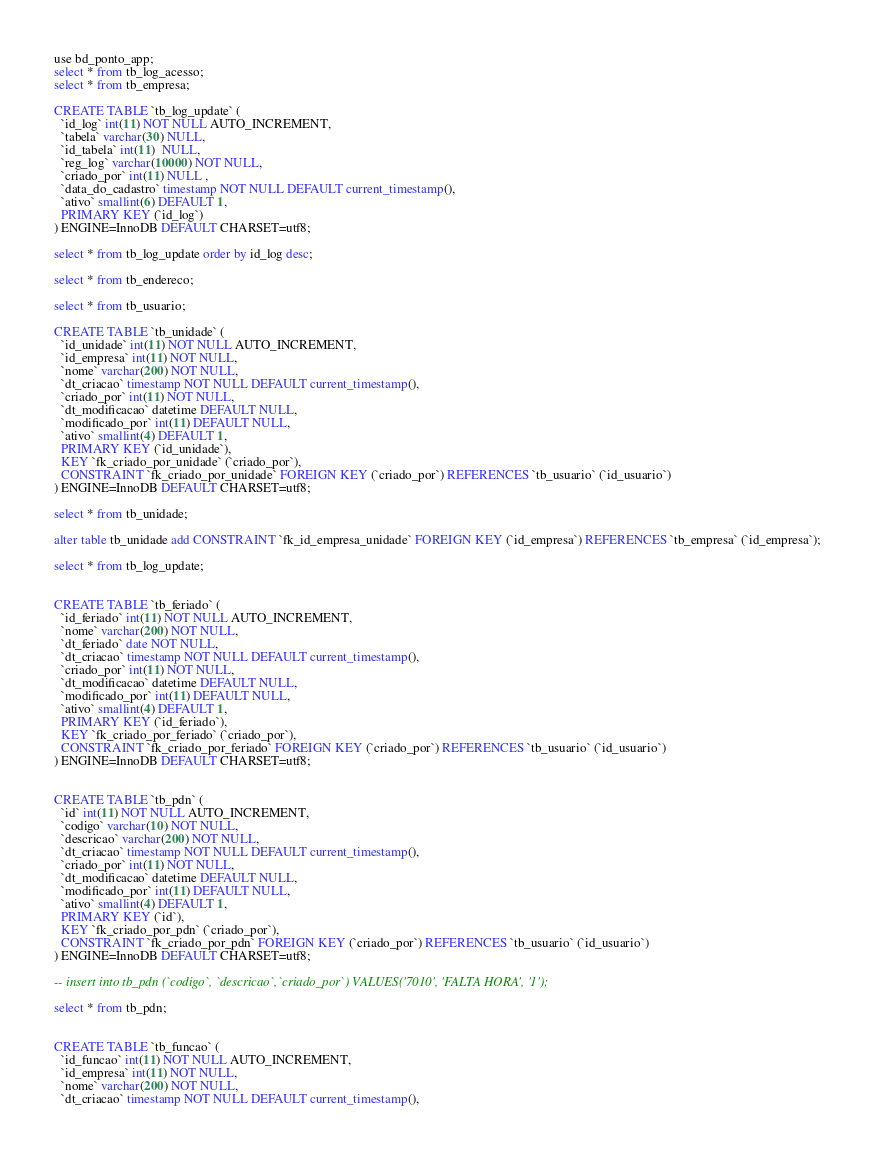Convert code to text. <code><loc_0><loc_0><loc_500><loc_500><_SQL_>use bd_ponto_app;
select * from tb_log_acesso;
select * from tb_empresa;

CREATE TABLE `tb_log_update` (
  `id_log` int(11) NOT NULL AUTO_INCREMENT,
  `tabela` varchar(30) NULL,
  `id_tabela` int(11)  NULL,
  `reg_log` varchar(10000) NOT NULL,
  `criado_por` int(11) NULL ,
  `data_do_cadastro` timestamp NOT NULL DEFAULT current_timestamp(),
  `ativo` smallint(6) DEFAULT 1,
  PRIMARY KEY (`id_log`)
) ENGINE=InnoDB DEFAULT CHARSET=utf8;

select * from tb_log_update order by id_log desc; 

select * from tb_endereco;

select * from tb_usuario;

CREATE TABLE `tb_unidade` (
  `id_unidade` int(11) NOT NULL AUTO_INCREMENT,
  `id_empresa` int(11) NOT NULL,
  `nome` varchar(200) NOT NULL,  
  `dt_criacao` timestamp NOT NULL DEFAULT current_timestamp(),
  `criado_por` int(11) NOT NULL,
  `dt_modificacao` datetime DEFAULT NULL,
  `modificado_por` int(11) DEFAULT NULL,
  `ativo` smallint(4) DEFAULT 1,
  PRIMARY KEY (`id_unidade`),
  KEY `fk_criado_por_unidade` (`criado_por`),
  CONSTRAINT `fk_criado_por_unidade` FOREIGN KEY (`criado_por`) REFERENCES `tb_usuario` (`id_usuario`)
) ENGINE=InnoDB DEFAULT CHARSET=utf8;

select * from tb_unidade;

alter table tb_unidade add CONSTRAINT `fk_id_empresa_unidade` FOREIGN KEY (`id_empresa`) REFERENCES `tb_empresa` (`id_empresa`);

select * from tb_log_update;


CREATE TABLE `tb_feriado` (
  `id_feriado` int(11) NOT NULL AUTO_INCREMENT,
  `nome` varchar(200) NOT NULL,
  `dt_feriado` date NOT NULL,
  `dt_criacao` timestamp NOT NULL DEFAULT current_timestamp(),
  `criado_por` int(11) NOT NULL,
  `dt_modificacao` datetime DEFAULT NULL,
  `modificado_por` int(11) DEFAULT NULL,
  `ativo` smallint(4) DEFAULT 1,
  PRIMARY KEY (`id_feriado`),
  KEY `fk_criado_por_feriado` (`criado_por`),
  CONSTRAINT `fk_criado_por_feriado` FOREIGN KEY (`criado_por`) REFERENCES `tb_usuario` (`id_usuario`)
) ENGINE=InnoDB DEFAULT CHARSET=utf8;


CREATE TABLE `tb_pdn` (
  `id` int(11) NOT NULL AUTO_INCREMENT,
  `codigo` varchar(10) NOT NULL,
  `descricao` varchar(200) NOT NULL,  
  `dt_criacao` timestamp NOT NULL DEFAULT current_timestamp(),
  `criado_por` int(11) NOT NULL,
  `dt_modificacao` datetime DEFAULT NULL,
  `modificado_por` int(11) DEFAULT NULL,
  `ativo` smallint(4) DEFAULT 1,
  PRIMARY KEY (`id`),
  KEY `fk_criado_por_pdn` (`criado_por`),
  CONSTRAINT `fk_criado_por_pdn` FOREIGN KEY (`criado_por`) REFERENCES `tb_usuario` (`id_usuario`)
) ENGINE=InnoDB DEFAULT CHARSET=utf8;

-- insert into tb_pdn (`codigo`, `descricao`,`criado_por`) VALUES('7010', 'FALTA HORA', '1'); 

select * from tb_pdn;


CREATE TABLE `tb_funcao` (
  `id_funcao` int(11) NOT NULL AUTO_INCREMENT,
  `id_empresa` int(11) NOT NULL,
  `nome` varchar(200) NOT NULL,  
  `dt_criacao` timestamp NOT NULL DEFAULT current_timestamp(),</code> 